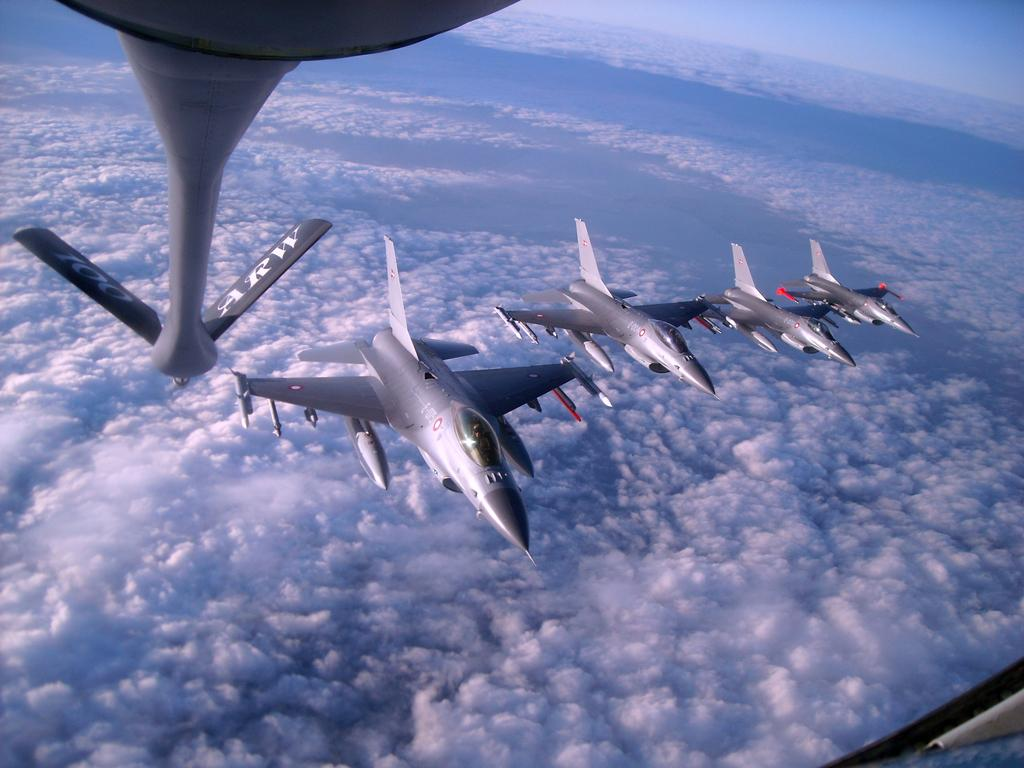What is in the sky in the image? There are aircraft in the sky in the image. Where are the aircraft located in relation to the image? The aircraft are in the foreground area of the image. What type of berry can be seen growing on the aircraft in the image? There are no berries present on the aircraft in the image. What type of paste is being used to stick the aircraft together in the image? The aircraft in the image are not being held together with any paste; they are flying in the sky. 